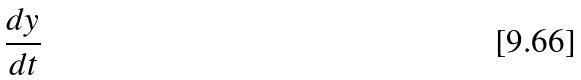<formula> <loc_0><loc_0><loc_500><loc_500>\frac { d y } { d t }</formula> 